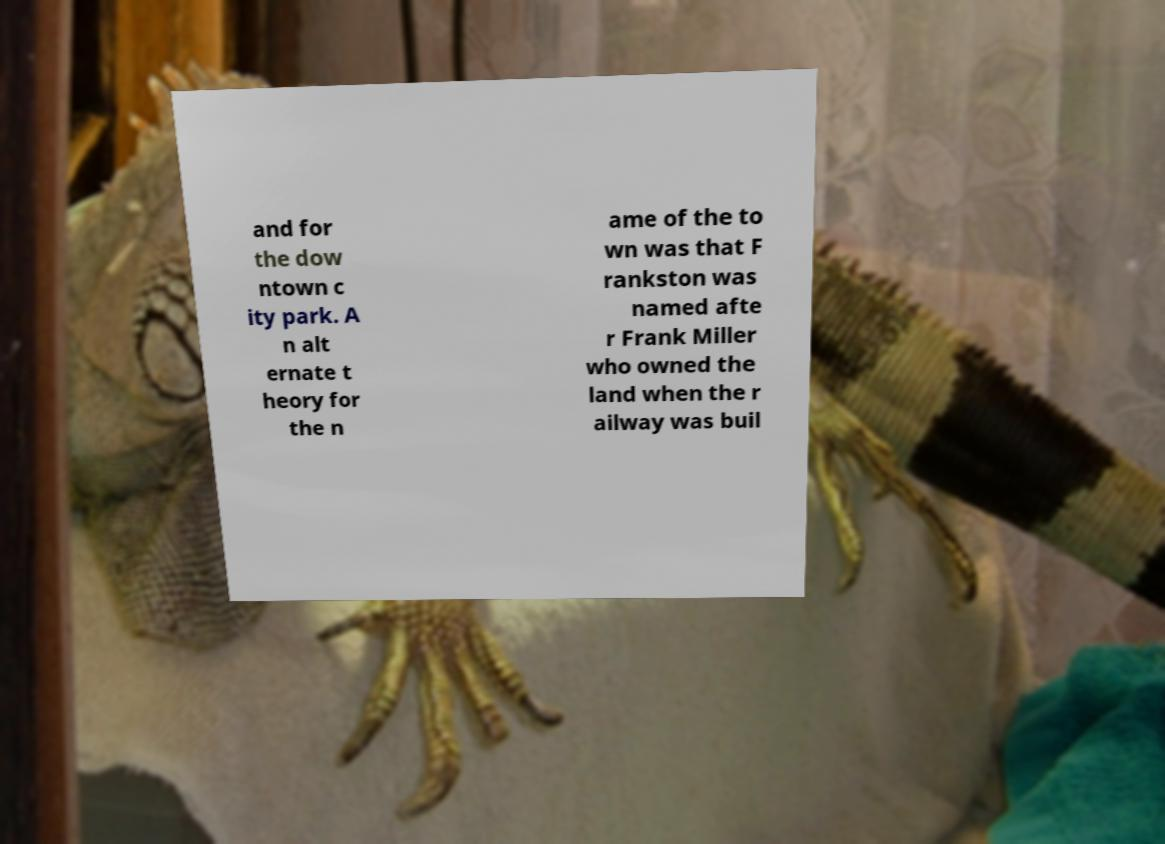Please identify and transcribe the text found in this image. and for the dow ntown c ity park. A n alt ernate t heory for the n ame of the to wn was that F rankston was named afte r Frank Miller who owned the land when the r ailway was buil 